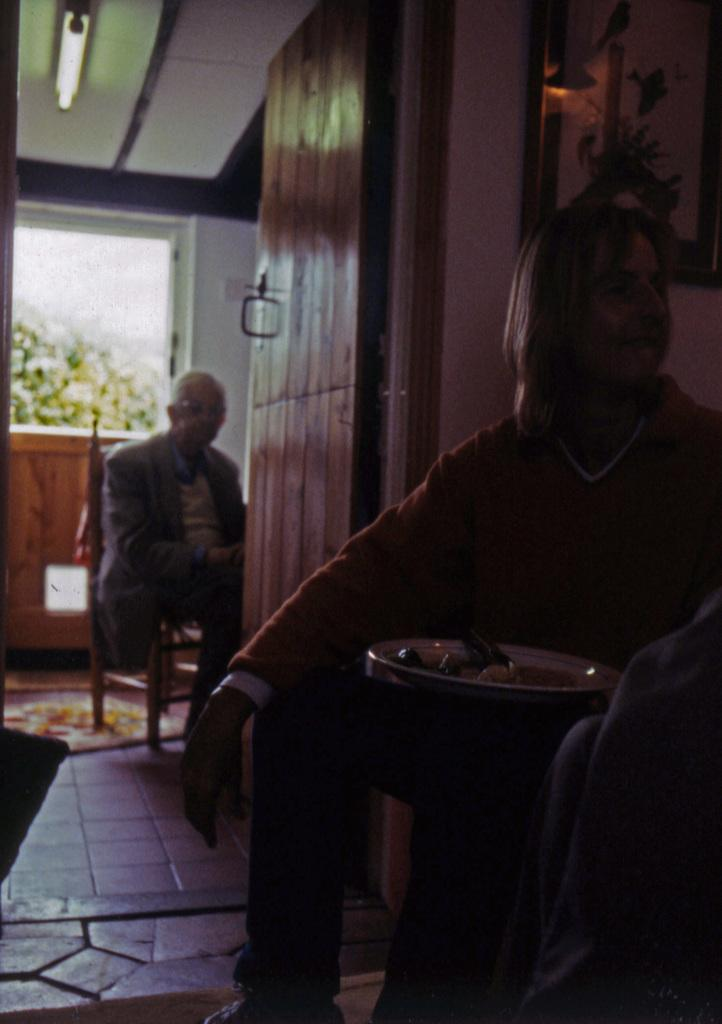How many persons are sitting in the image? There are two persons sitting on chairs in the image. What can be seen on the floor? The floor is visible in the image, and there is a mat on the floor. What objects are present on the mat? There is a plate and a glass on the mat. What is the purpose of the frame in the image? The purpose of the frame is not clear from the image, but it could be used for displaying a picture or artwork. What is the source of light in the image? There is a light in the image. What type of screw can be seen holding the chair together in the image? There is no screw visible in the image; it only shows two persons sitting on chairs. What taste can be experienced from the plate in the image? The image does not provide any information about the taste of the contents on the plate. 